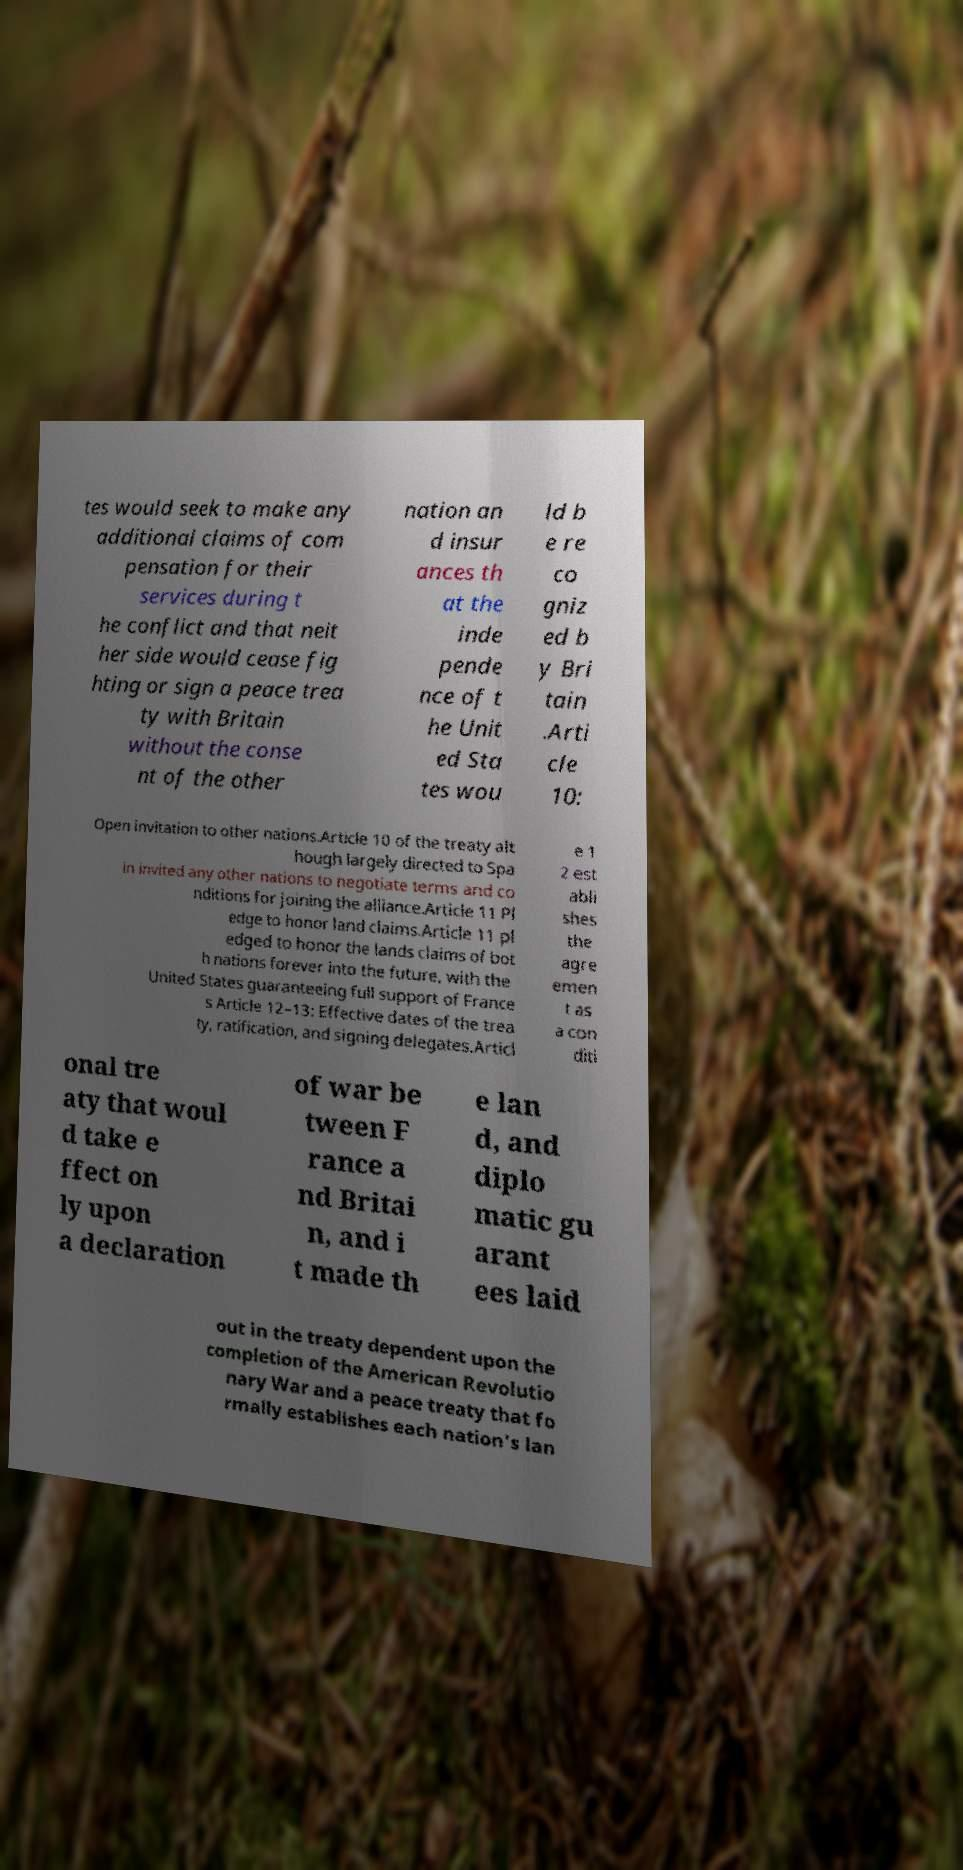Please read and relay the text visible in this image. What does it say? tes would seek to make any additional claims of com pensation for their services during t he conflict and that neit her side would cease fig hting or sign a peace trea ty with Britain without the conse nt of the other nation an d insur ances th at the inde pende nce of t he Unit ed Sta tes wou ld b e re co gniz ed b y Bri tain .Arti cle 10: Open invitation to other nations.Article 10 of the treaty alt hough largely directed to Spa in invited any other nations to negotiate terms and co nditions for joining the alliance.Article 11 Pl edge to honor land claims.Article 11 pl edged to honor the lands claims of bot h nations forever into the future, with the United States guaranteeing full support of France s Article 12–13: Effective dates of the trea ty, ratification, and signing delegates.Articl e 1 2 est abli shes the agre emen t as a con diti onal tre aty that woul d take e ffect on ly upon a declaration of war be tween F rance a nd Britai n, and i t made th e lan d, and diplo matic gu arant ees laid out in the treaty dependent upon the completion of the American Revolutio nary War and a peace treaty that fo rmally establishes each nation's lan 